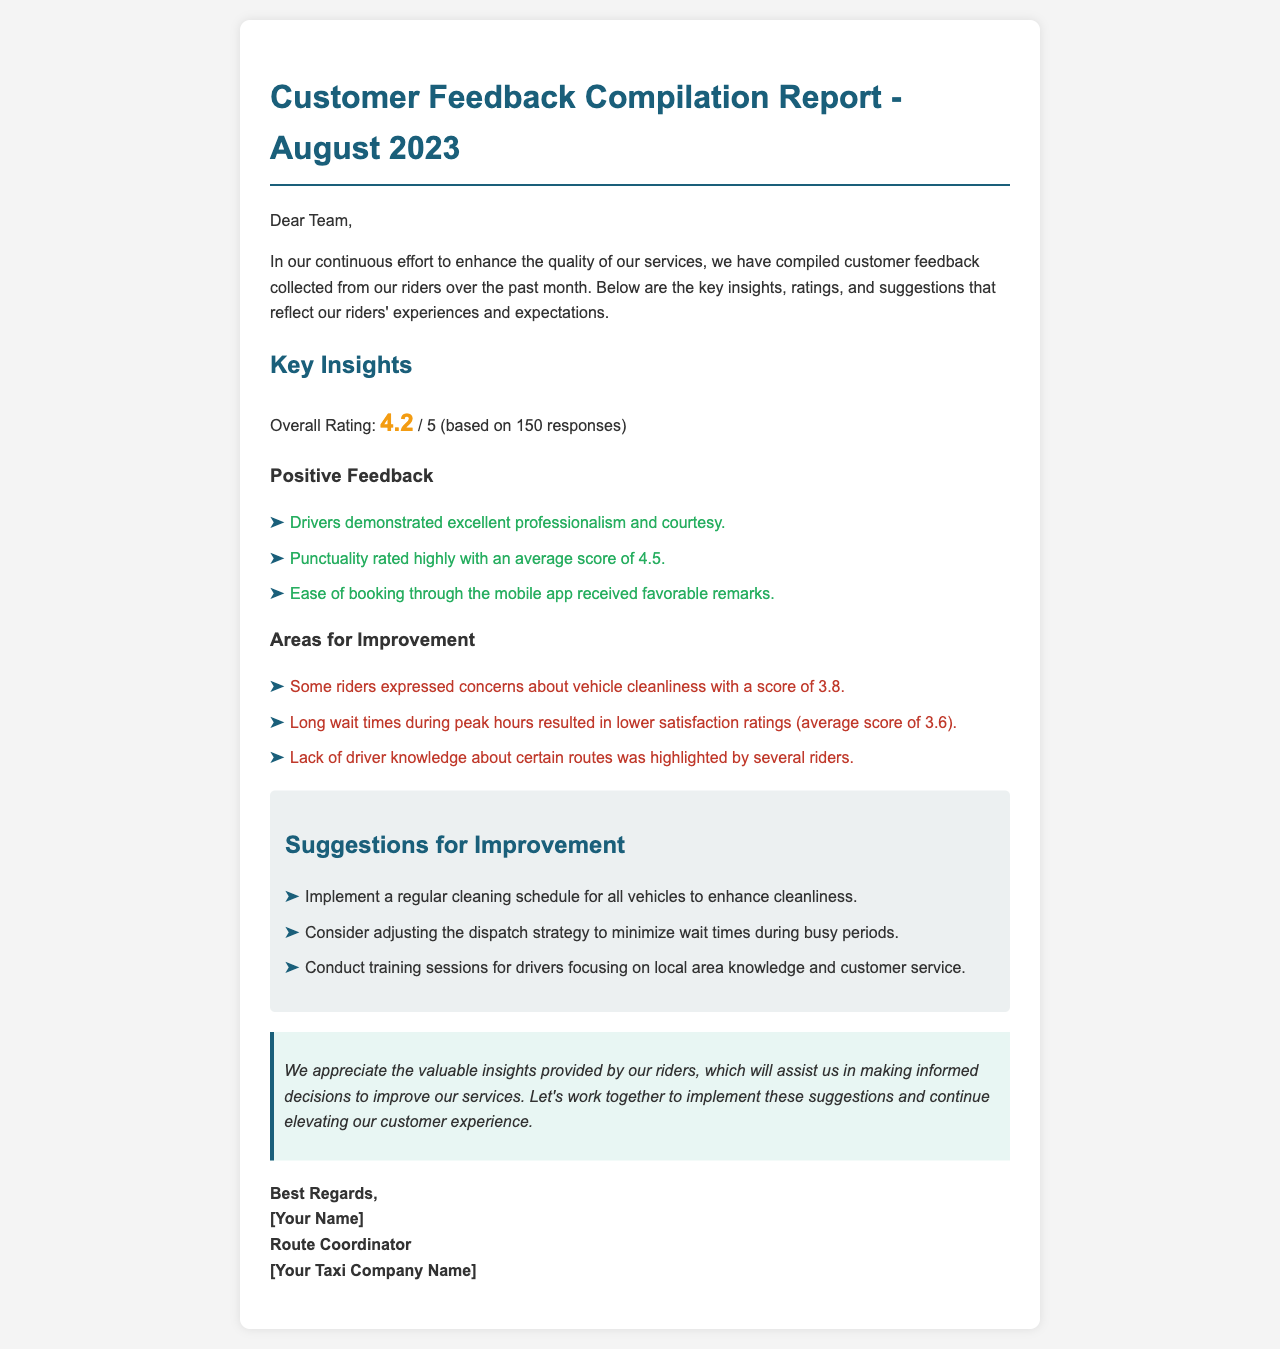What is the overall rating given by customers? The overall rating is mentioned in the document based on the feedback collected, which is 4.2 out of 5.
Answer: 4.2 How many responses were considered for this report? The document specifies that the feedback was based on 150 responses from riders.
Answer: 150 What average score did punctuality receive? The average score for punctuality reflects the rider's satisfaction level regarding on-time arrivals, which is noted as 4.5.
Answer: 4.5 What was the average score related to vehicle cleanliness? The document highlights concerns about vehicle cleanliness with a specific average score given by riders, noted as 3.8.
Answer: 3.8 What suggestion is given to enhance vehicle cleanliness? A specific suggestion provided aims at increasing cleanliness standards, which is to implement a regular cleaning schedule for all vehicles.
Answer: Regular cleaning schedule What was identified as an issue during peak hours? The document mentions long wait times during peak hours as an area needing improvement, which affected rider satisfaction ratings.
Answer: Long wait times Which areas should be focused on in driver training? The suggestions outline key areas for driver training, focusing on local area knowledge and customer service as important aspects.
Answer: Local area knowledge and customer service What is the primary purpose of this feedback report? The main intention behind compiling this report is to enhance the quality of services based on customer feedback.
Answer: Enhance service quality Who is the sender of this report? The report concludes with a signature indicating the sender as the Route Coordinator of the taxi company.
Answer: Route Coordinator 